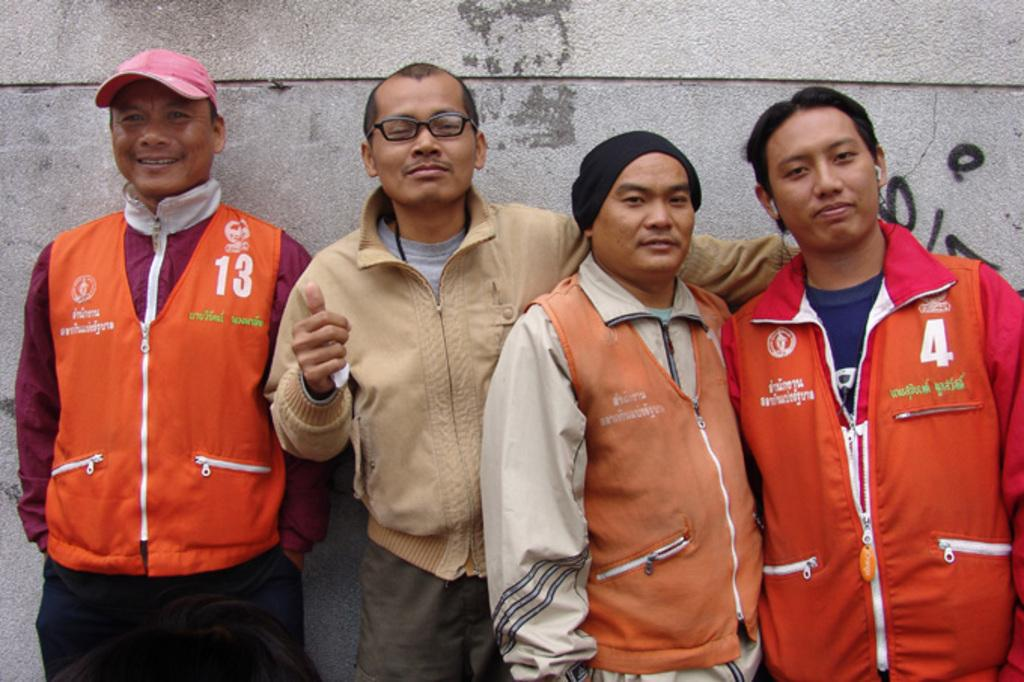Provide a one-sentence caption for the provided image. four guys posing for a photo, one is waring a vest with 123 on it and another guy has number 4 on his jacket. 